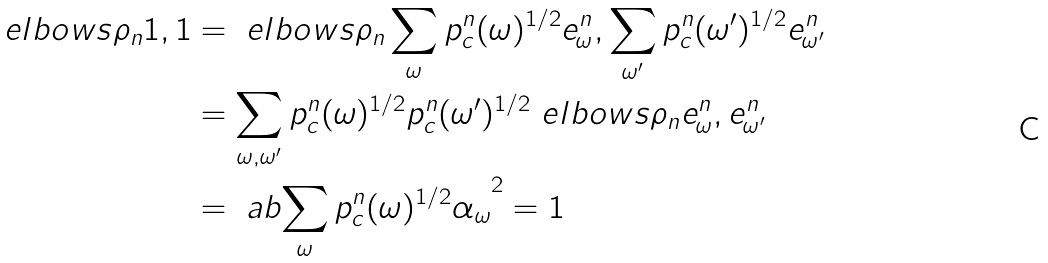<formula> <loc_0><loc_0><loc_500><loc_500>\ e l b o w s { \rho _ { n } 1 , 1 } & = \ e l b o w s { \rho _ { n } \sum _ { \omega } p _ { c } ^ { n } ( \omega ) ^ { 1 / 2 } e _ { \omega } ^ { n } , \sum _ { \omega ^ { \prime } } p _ { c } ^ { n } ( \omega ^ { \prime } ) ^ { 1 / 2 } e _ { \omega ^ { \prime } } ^ { n } } \\ & = \sum _ { \omega , \omega ^ { \prime } } p _ { c } ^ { n } ( \omega ) ^ { 1 / 2 } p _ { c } ^ { n } ( \omega ^ { \prime } ) ^ { 1 / 2 } \ e l b o w s { \rho _ { n } e _ { \omega } ^ { n } , e _ { \omega ^ { \prime } } ^ { n } } \\ & = \ a b { \sum _ { \omega } p _ { c } ^ { n } ( \omega ) ^ { 1 / 2 } \alpha _ { \omega } } ^ { 2 } = 1</formula> 